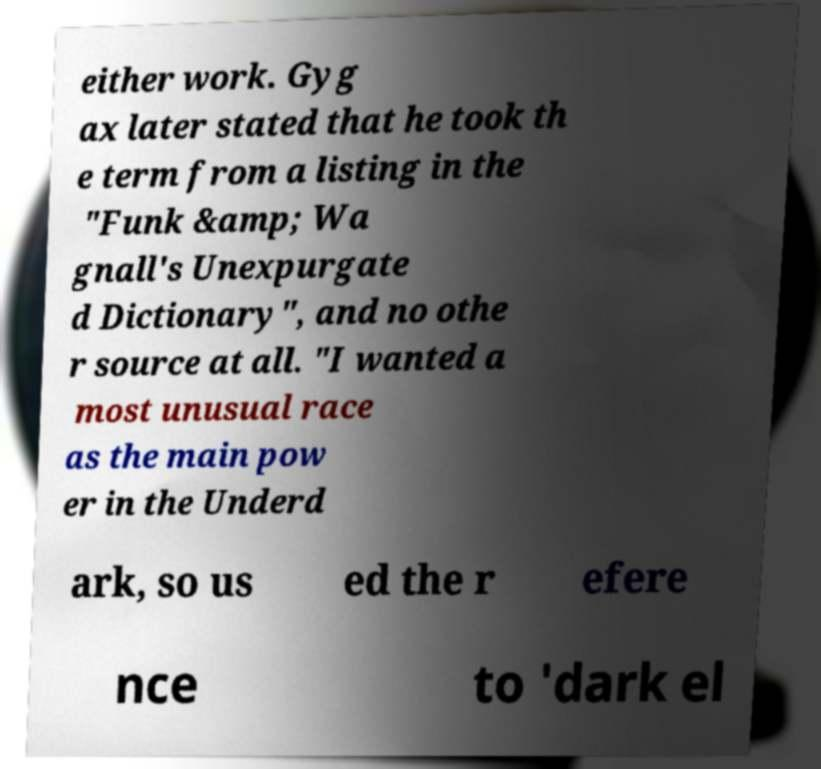I need the written content from this picture converted into text. Can you do that? either work. Gyg ax later stated that he took th e term from a listing in the "Funk &amp; Wa gnall's Unexpurgate d Dictionary", and no othe r source at all. "I wanted a most unusual race as the main pow er in the Underd ark, so us ed the r efere nce to 'dark el 